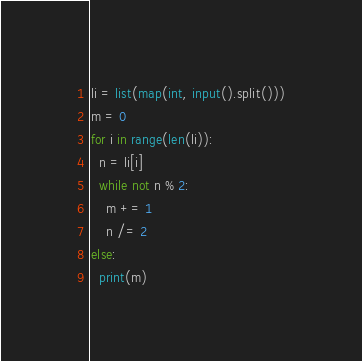<code> <loc_0><loc_0><loc_500><loc_500><_Python_>li = list(map(int, input().split()))
m = 0
for i in range(len(li)):
  n = li[i]
  while not n % 2:
    m += 1
    n /= 2
else:
  print(m)</code> 